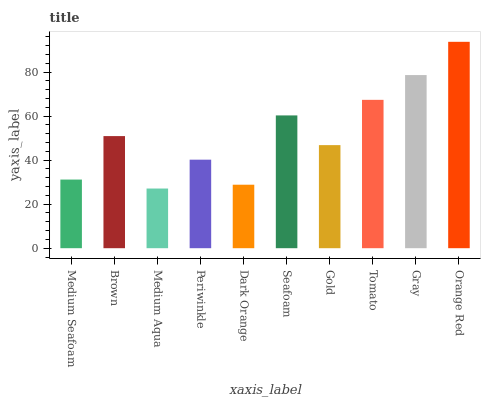Is Medium Aqua the minimum?
Answer yes or no. Yes. Is Orange Red the maximum?
Answer yes or no. Yes. Is Brown the minimum?
Answer yes or no. No. Is Brown the maximum?
Answer yes or no. No. Is Brown greater than Medium Seafoam?
Answer yes or no. Yes. Is Medium Seafoam less than Brown?
Answer yes or no. Yes. Is Medium Seafoam greater than Brown?
Answer yes or no. No. Is Brown less than Medium Seafoam?
Answer yes or no. No. Is Brown the high median?
Answer yes or no. Yes. Is Gold the low median?
Answer yes or no. Yes. Is Tomato the high median?
Answer yes or no. No. Is Seafoam the low median?
Answer yes or no. No. 